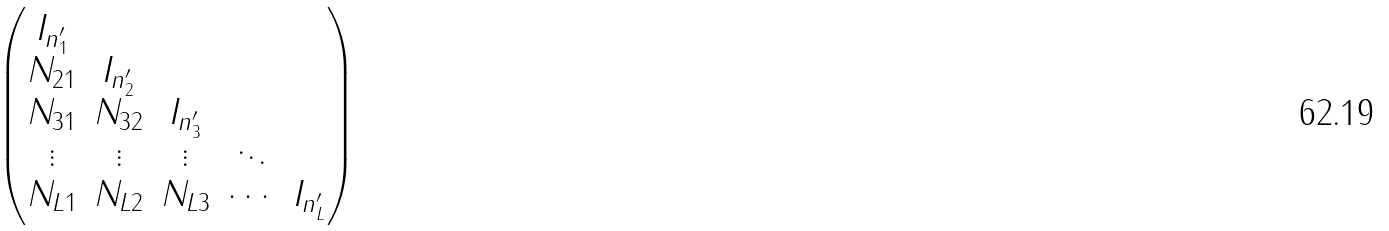Convert formula to latex. <formula><loc_0><loc_0><loc_500><loc_500>\begin{pmatrix} I _ { n ^ { \prime } _ { 1 } } & & & & \\ N _ { 2 1 } & I _ { n ^ { \prime } _ { 2 } } & & & \\ N _ { 3 1 } & N _ { 3 2 } & I _ { n ^ { \prime } _ { 3 } } & & \\ \vdots & \vdots & \vdots & \ddots & \\ N _ { L 1 } & N _ { L 2 } & N _ { L 3 } & \cdots & I _ { n ^ { \prime } _ { L } } \end{pmatrix}</formula> 